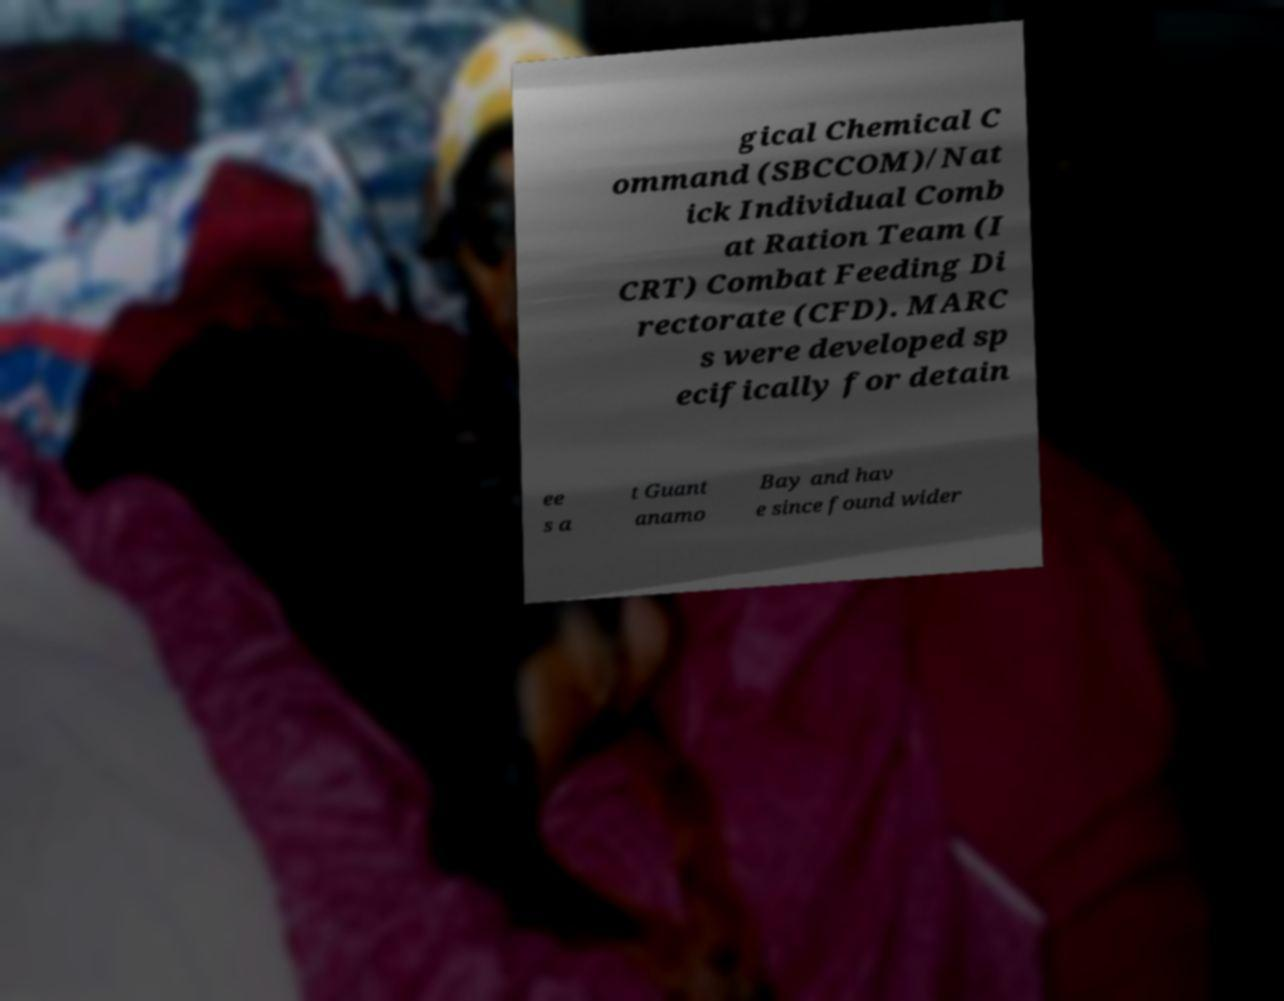Please identify and transcribe the text found in this image. gical Chemical C ommand (SBCCOM)/Nat ick Individual Comb at Ration Team (I CRT) Combat Feeding Di rectorate (CFD). MARC s were developed sp ecifically for detain ee s a t Guant anamo Bay and hav e since found wider 